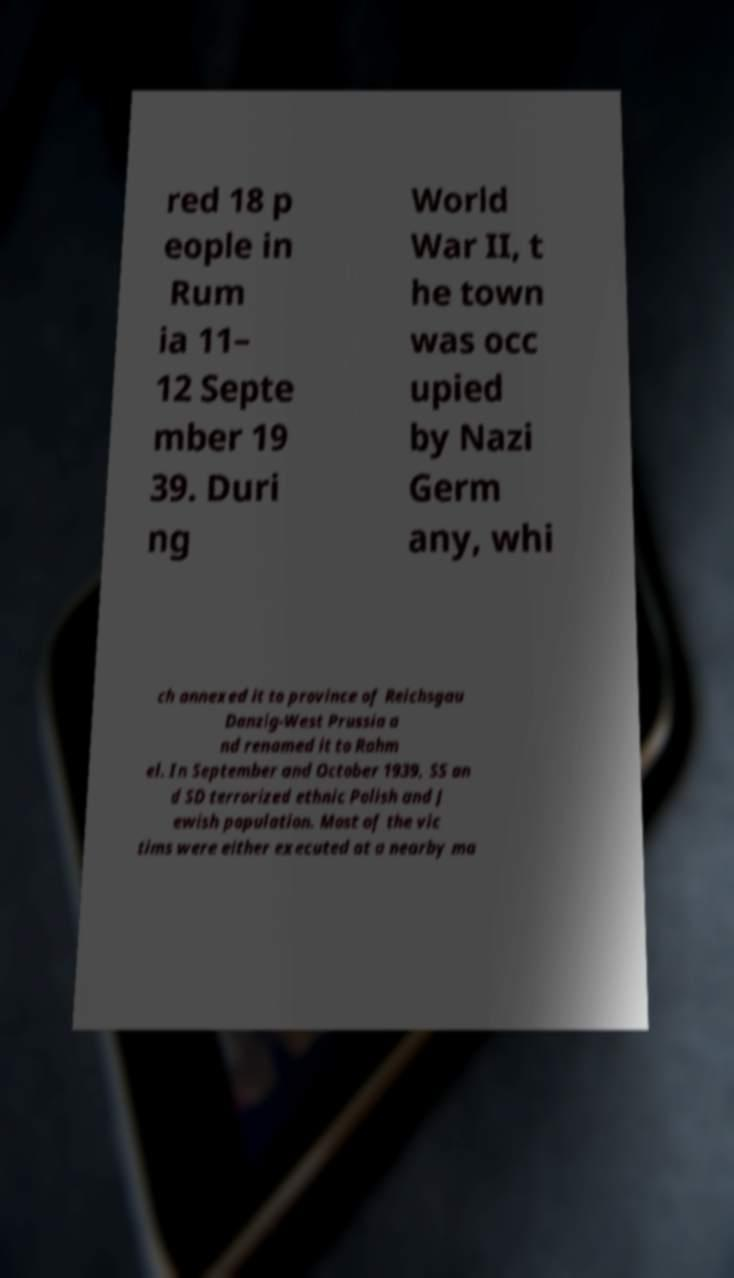For documentation purposes, I need the text within this image transcribed. Could you provide that? red 18 p eople in Rum ia 11– 12 Septe mber 19 39. Duri ng World War II, t he town was occ upied by Nazi Germ any, whi ch annexed it to province of Reichsgau Danzig-West Prussia a nd renamed it to Rahm el. In September and October 1939, SS an d SD terrorized ethnic Polish and J ewish population. Most of the vic tims were either executed at a nearby ma 